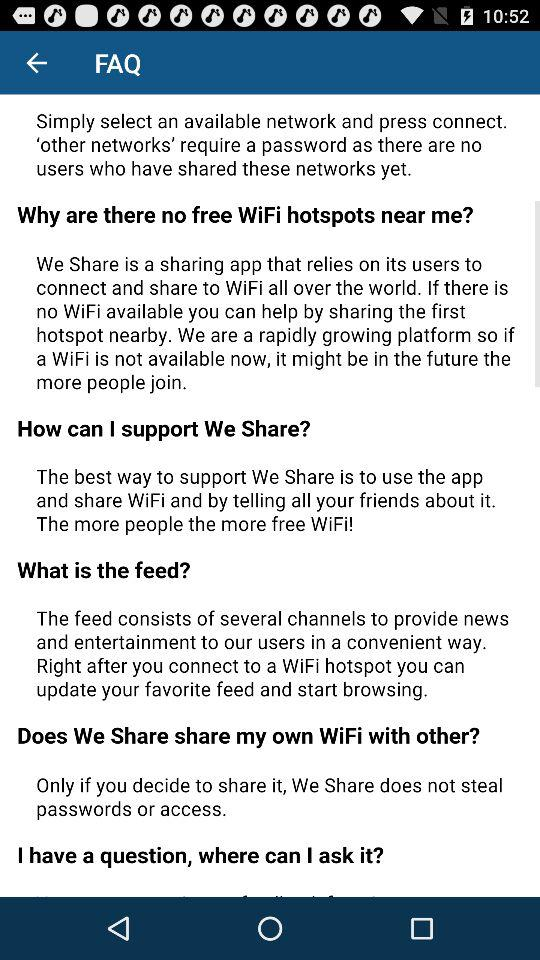How many FAQ items are there?
Answer the question using a single word or phrase. 5 